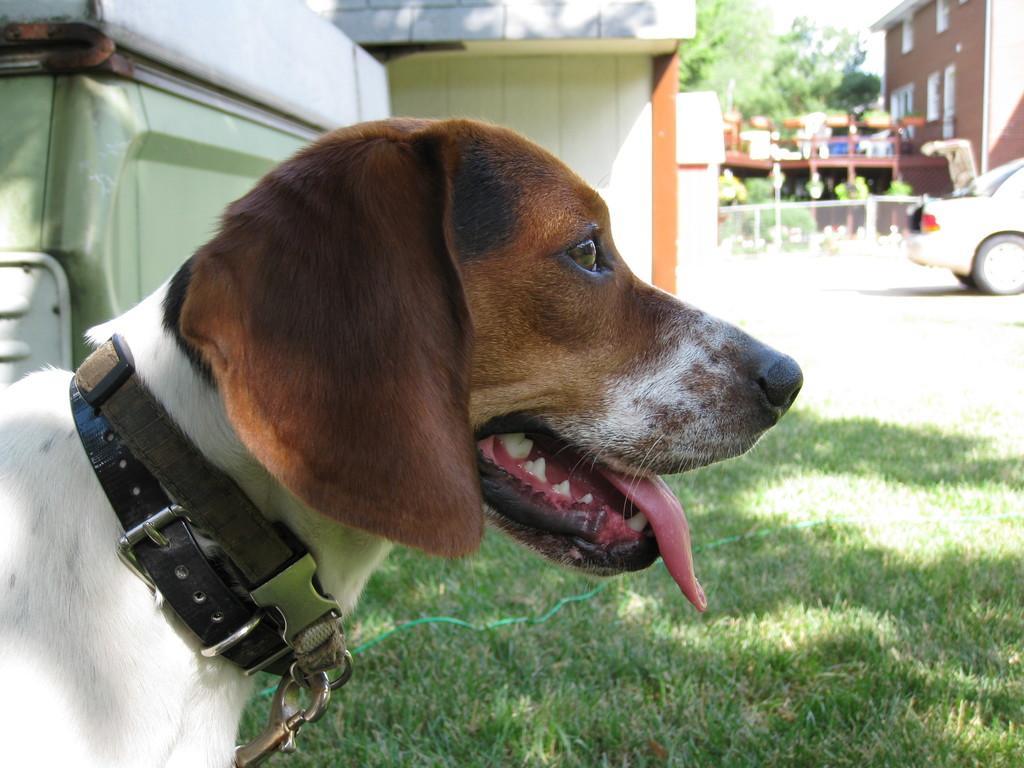Please provide a concise description of this image. This picture is clicked outside. In the foreground we can see a dog seems to be standing and we can see the green grass, trees and a building and we can see a car and some other objects and we can see the metal rods, mesh. 